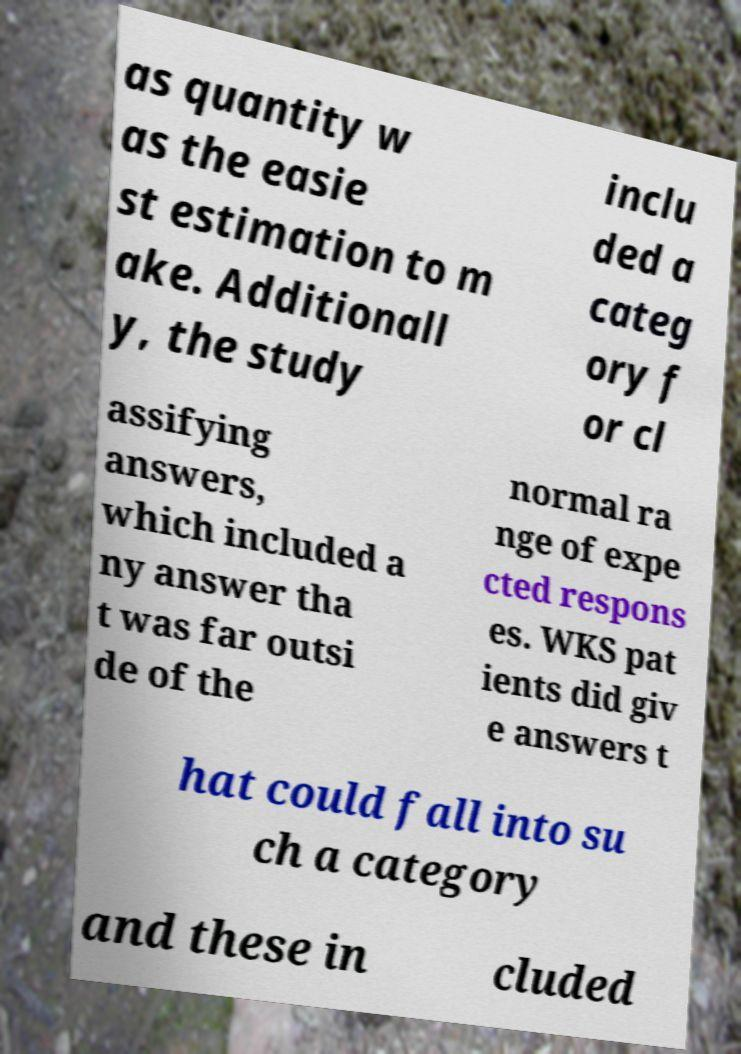I need the written content from this picture converted into text. Can you do that? as quantity w as the easie st estimation to m ake. Additionall y, the study inclu ded a categ ory f or cl assifying answers, which included a ny answer tha t was far outsi de of the normal ra nge of expe cted respons es. WKS pat ients did giv e answers t hat could fall into su ch a category and these in cluded 